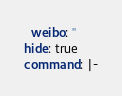<code> <loc_0><loc_0><loc_500><loc_500><_YAML_>  weibo: ''
hide: true
command: |-</code> 